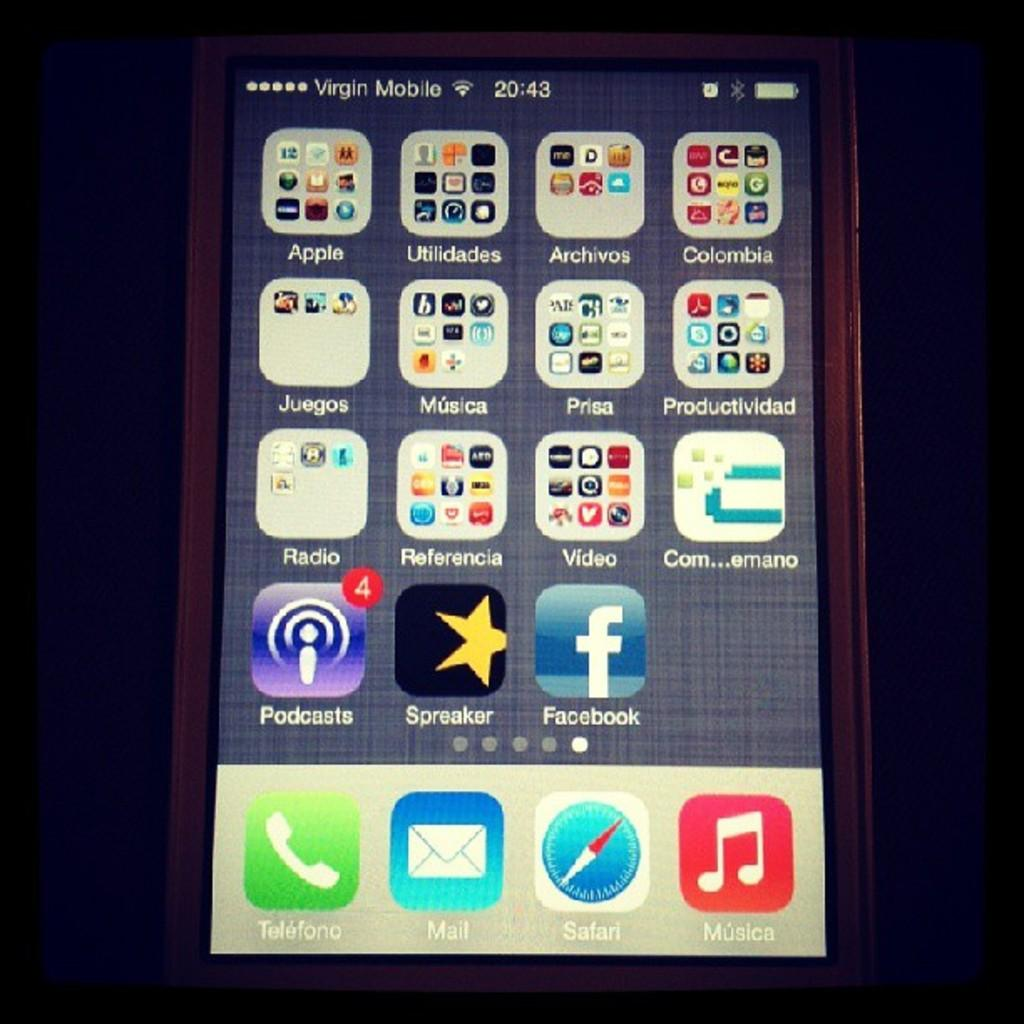<image>
Create a compact narrative representing the image presented. An iphone is on and has the home screen pulled up with facebook, podcasts and many other apps on it. 